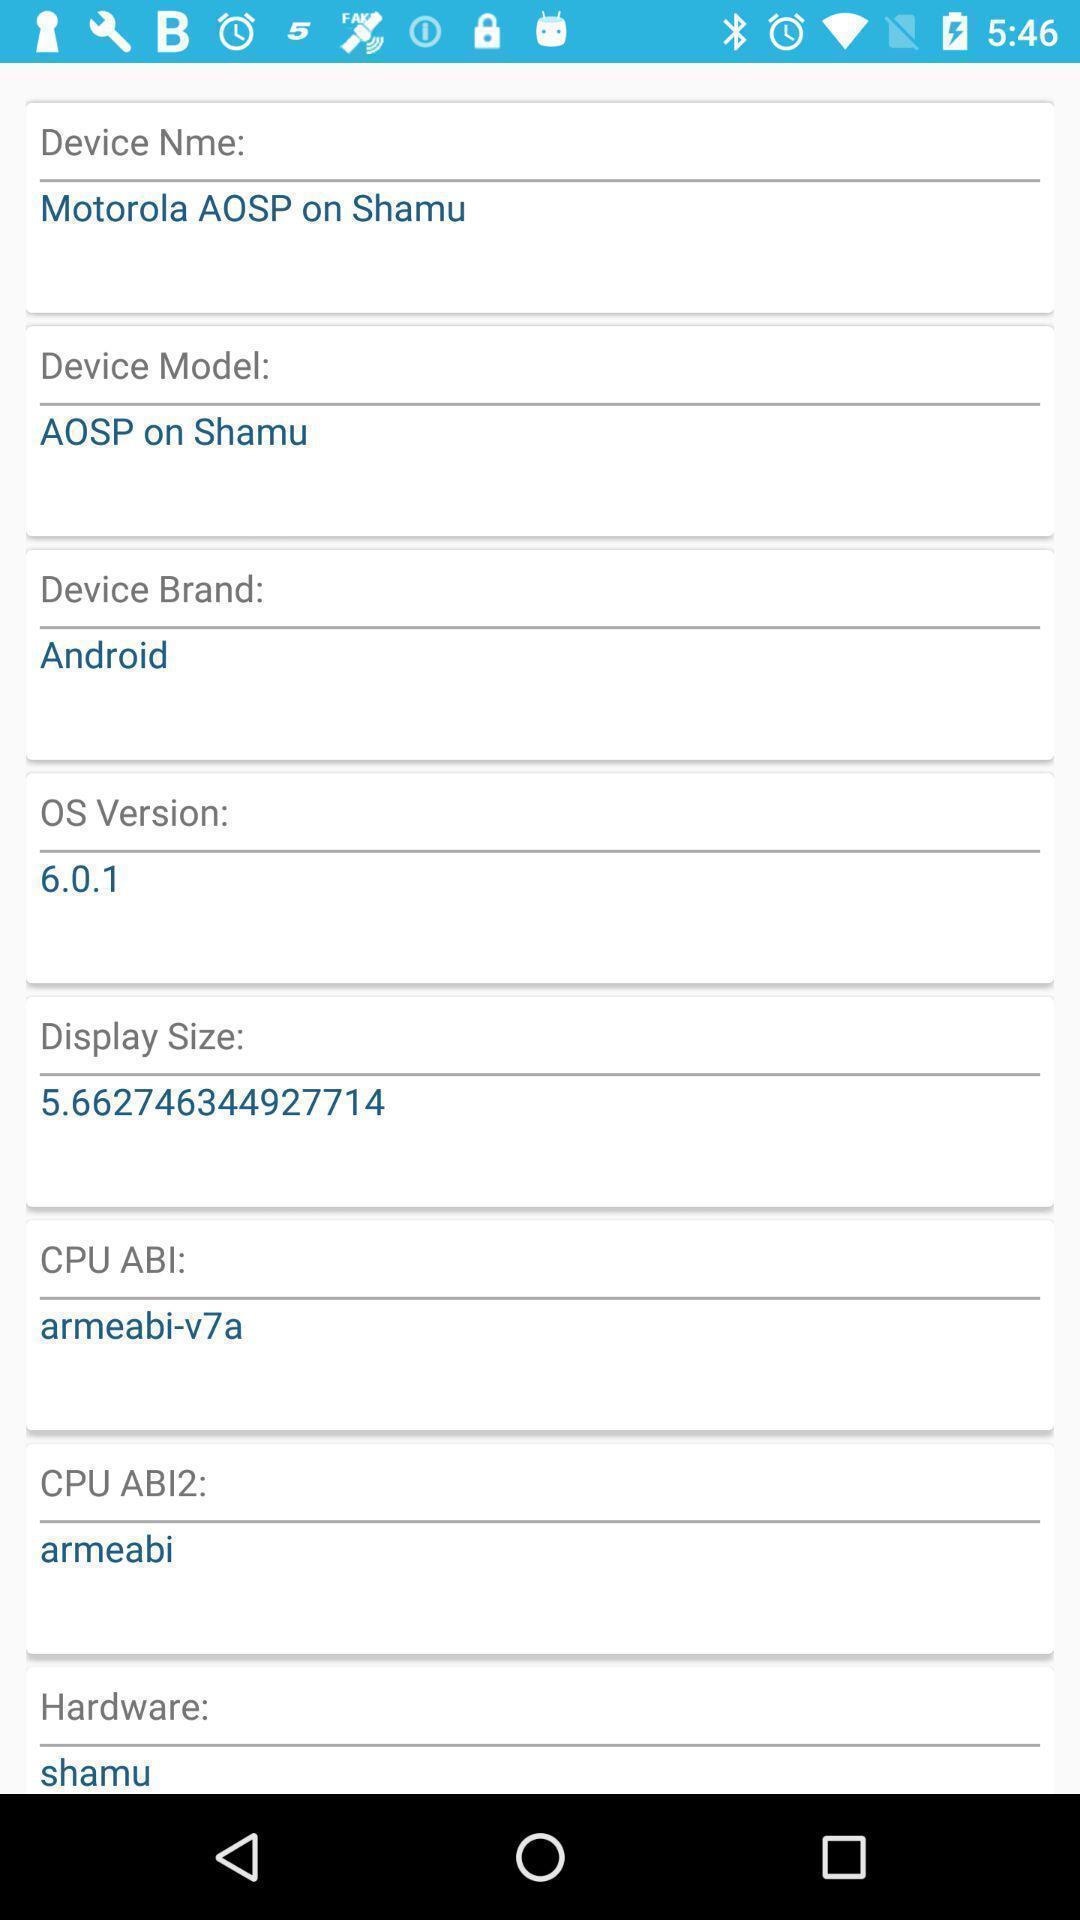Describe the key features of this screenshot. Page displays details of android. 